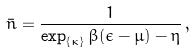Convert formula to latex. <formula><loc_0><loc_0><loc_500><loc_500>\bar { n } = \frac { 1 } { \exp _ { \{ \kappa \} } \beta ( \epsilon - \mu ) - \eta } \, ,</formula> 